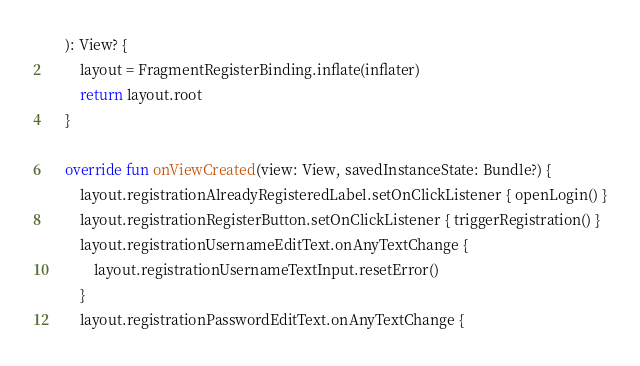<code> <loc_0><loc_0><loc_500><loc_500><_Kotlin_>    ): View? {
        layout = FragmentRegisterBinding.inflate(inflater)
        return layout.root
    }

    override fun onViewCreated(view: View, savedInstanceState: Bundle?) {
        layout.registrationAlreadyRegisteredLabel.setOnClickListener { openLogin() }
        layout.registrationRegisterButton.setOnClickListener { triggerRegistration() }
        layout.registrationUsernameEditText.onAnyTextChange {
            layout.registrationUsernameTextInput.resetError()
        }
        layout.registrationPasswordEditText.onAnyTextChange {</code> 